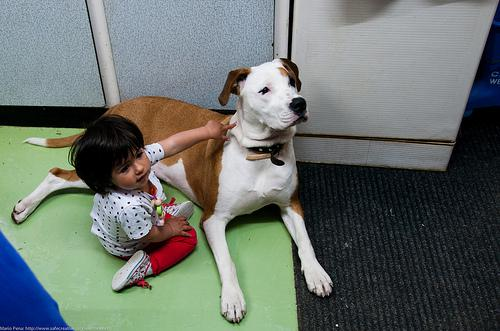Question: what colors are the dog?
Choices:
A. Black and white.
B. Gray and white.
C. Silver and white.
D. Brown and white.
Answer with the letter. Answer: D Question: who is pictured?
Choices:
A. An old man.
B. A grandmother.
C. A child.
D. Three little boys.
Answer with the letter. Answer: C Question: what color is the child's pants?
Choices:
A. Orange.
B. Pink.
C. Brown.
D. Red.
Answer with the letter. Answer: D Question: what pattern is on the child's shirt?
Choices:
A. Plaid.
B. Stripes.
C. Polka dots.
D. Flowers.
Answer with the letter. Answer: C 